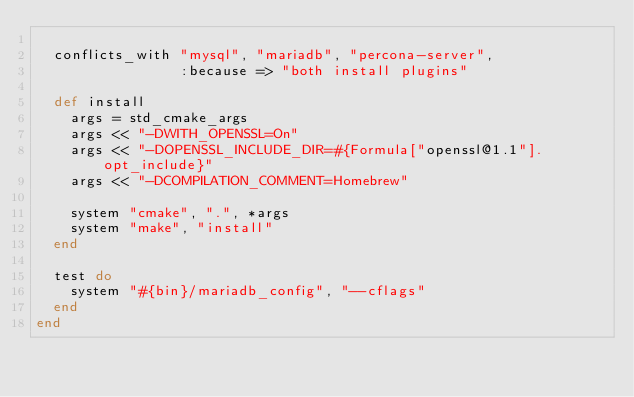<code> <loc_0><loc_0><loc_500><loc_500><_Ruby_>
  conflicts_with "mysql", "mariadb", "percona-server",
                 :because => "both install plugins"

  def install
    args = std_cmake_args
    args << "-DWITH_OPENSSL=On"
    args << "-DOPENSSL_INCLUDE_DIR=#{Formula["openssl@1.1"].opt_include}"
    args << "-DCOMPILATION_COMMENT=Homebrew"

    system "cmake", ".", *args
    system "make", "install"
  end

  test do
    system "#{bin}/mariadb_config", "--cflags"
  end
end
</code> 